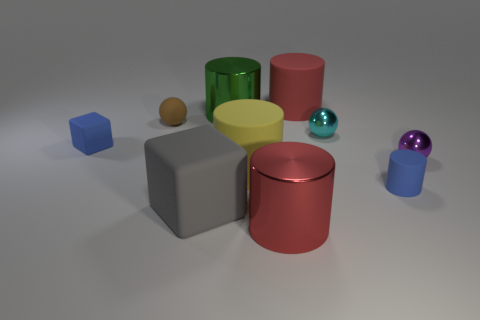What color is the tiny rubber thing right of the small sphere on the left side of the big matte cylinder behind the matte sphere? The small object to the right of the tiny sphere on the left side, located behind the large matte cylinder and itself matte, is blue. It's a rubbery texture, suggesting it might be soft or pliable, which contrasts with the hard surfaces of the other geometric objects surrounding it. 